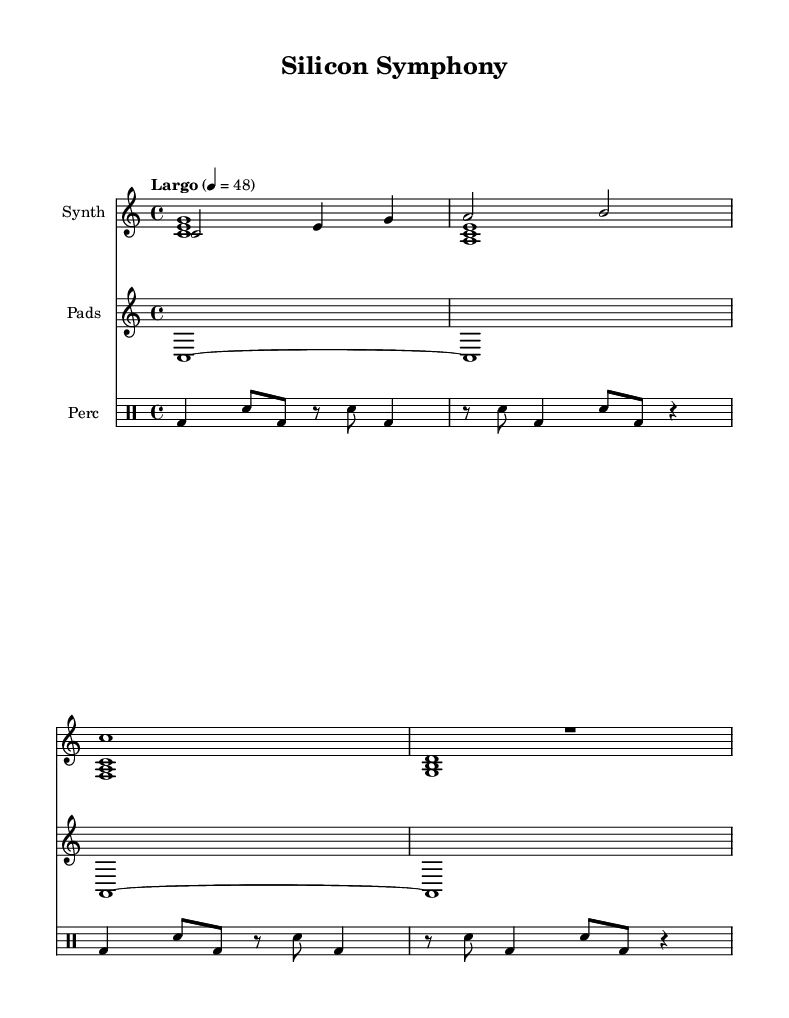What is the key signature of this music? The key signature shown at the beginning of the score indicates C major, which has no sharps or flats.
Answer: C major What is the time signature of the piece? The time signature displayed in the score is 4/4, meaning there are four beats in each measure and a quarter note receives one beat.
Answer: 4/4 What is the tempo marking for the music? The tempo marking is found at the beginning of the score, indicating that the piece should be played at a Largo tempo, specifically 48 beats per minute.
Answer: Largo 4 = 48 How many measures are in the synthesizer part? Counting the measures in the synthesizer part, there are a total of four measures shown.
Answer: 4 measures What is the highest note played by the electric piano? Reviewing the electric piano part, the highest note played is a D, which occurs in the last chord of the sequence.
Answer: D Which instrument plays a bass drum (bd) in the percussion section? The percussion part includes a bass drum indicated by the abbreviation "bd," which is present in multiple measures of the percussion section.
Answer: Bass drum What type of texture is primarily present in this soundtrack? The piece exhibits a layered texture with multiple voices and pads, creating an ambient soundscape typical of soundtracks designed to emulate complex environments like data centers.
Answer: Layered texture 